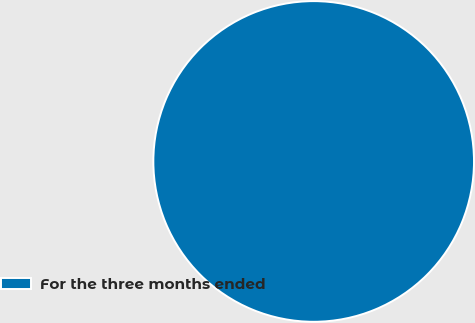Convert chart to OTSL. <chart><loc_0><loc_0><loc_500><loc_500><pie_chart><fcel>For the three months ended<nl><fcel>100.0%<nl></chart> 